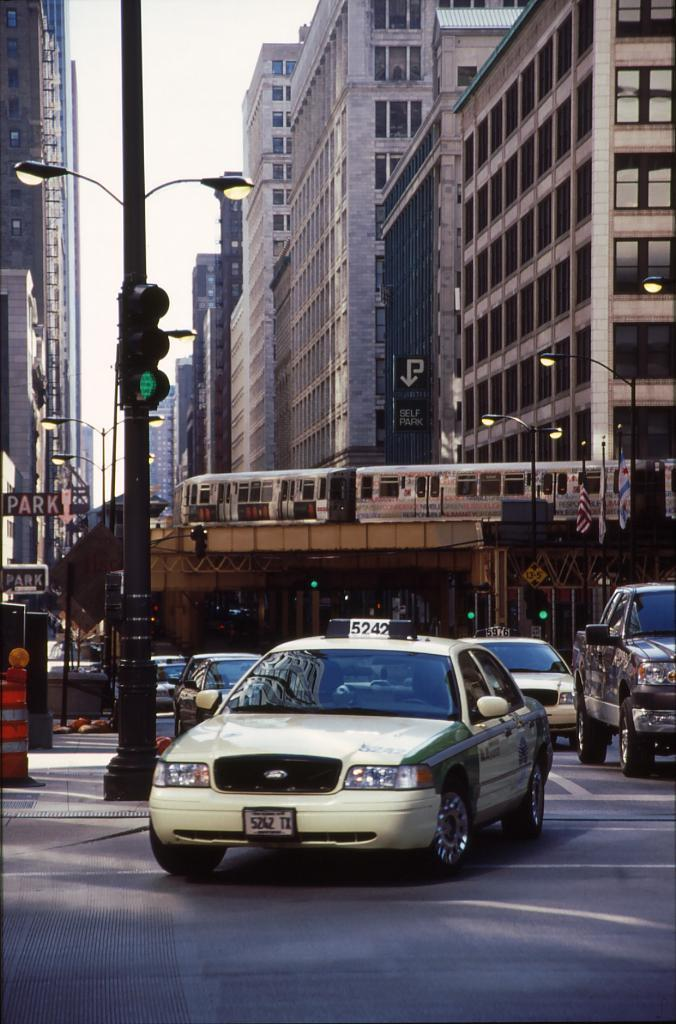<image>
Create a compact narrative representing the image presented. A taxi cab beneath a monorail with the number 5242 on the top 